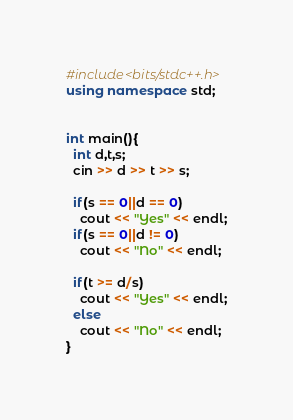<code> <loc_0><loc_0><loc_500><loc_500><_C++_>#include<bits/stdc++.h>
using namespace std;


int main(){
  int d,t,s;
  cin >> d >> t >> s;
  
  if(s == 0||d == 0)
    cout << "Yes" << endl;
  if(s == 0||d != 0)
    cout << "No" << endl;
  
  if(t >= d/s)
    cout << "Yes" << endl;
  else
    cout << "No" << endl;
}
</code> 